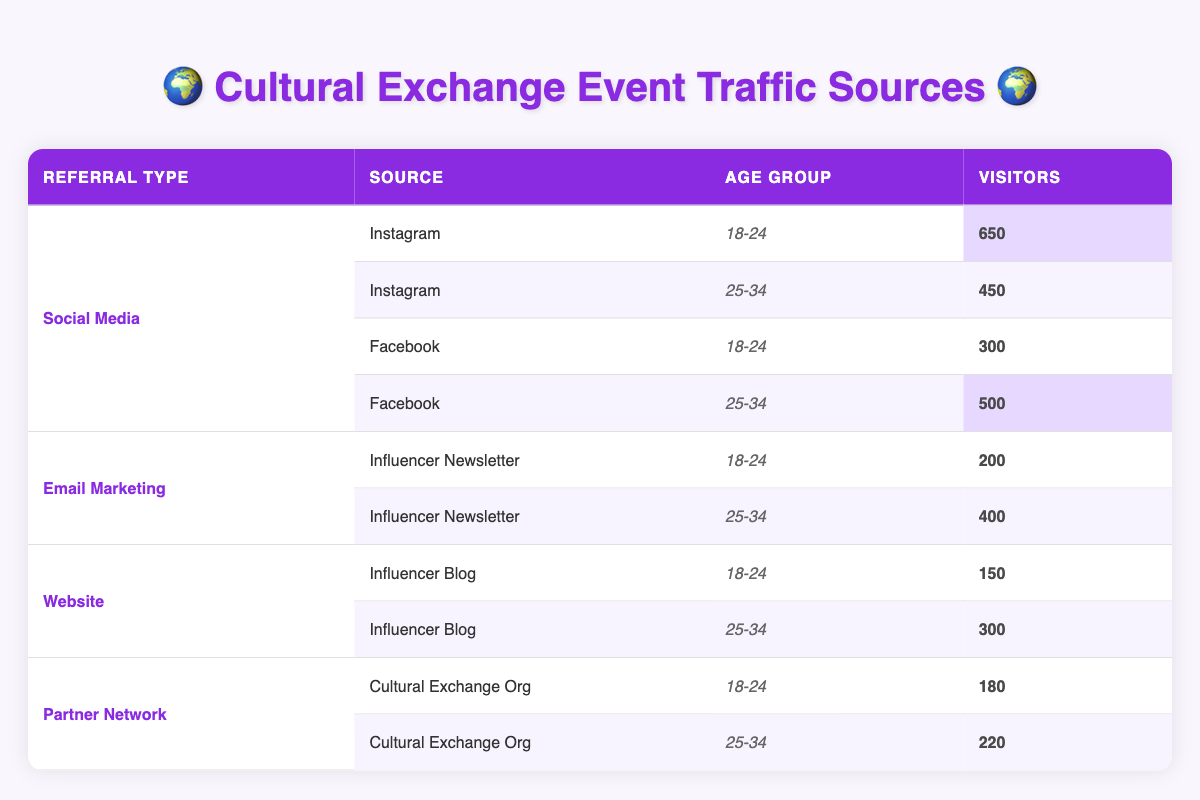What is the total number of visitors from Instagram aged 18-24? From the table, the value for Instagram in the age group 18-24 is 650 visitors. Since there are no other entries for Instagram under this age group, the total count remains 650.
Answer: 650 How many visitors came from Email Marketing in the age group 25-34? According to the table, for Email Marketing with the campaign "Influencer Newsletter" in the age group 25-34, there are 400 visitors.
Answer: 400 Which referral type had the highest number of visitors in the 18-24 age group? In the 18-24 age group, Social Media (Instagram) has the highest number of visitors at 650, compared to other referral types.
Answer: Social Media (Instagram) What is the difference in the number of visitors from Facebook between the two age groups? The number of visitors from Facebook is 300 for the 18-24 age group and 500 for the 25-34 age group. The difference is 500 - 300 = 200.
Answer: 200 Did more visitors come from the Influencer Newsletter or the Influencer Blog in the 25-34 age group? For the 25-34 age group, the Influencer Newsletter has 400 visitors while the Influencer Blog has 300 visitors. So, more visitors came from the Influencer Newsletter.
Answer: Yes What is the total number of visitors from all sources combined for the 25-34 age group? Adding the visitors for the 25-34 age group: Instagram (450) + Facebook (500) + Email Marketing (400) + Influencer Blog (300) + Partner Network (220) gives a total of 450 + 500 + 400 + 300 + 220 = 1870 visitors.
Answer: 1870 From which source in the Partner Network did the 18-24 age group have more visitors? The table indicates that in the 18-24 age group, the "Cultural Exchange Org" from the Partner Network had 180 visitors. There are no other sources listed for this age group in the Partner Network, so the answer is 180.
Answer: 180 What percentage of the total visitors from Social Media came from Instagram in the 25-34 age group? For Social Media in the 25-34 age group, the total visitors from Instagram is 450, and from Facebook is 500, making the total 950. Thus, the percentage for Instagram is (450/950)*100 = 47.37%, which rounds to approximately 47%.
Answer: 47% Which referral type had the least number of visitors in the 18-24 age group? In the 18-24 age group, the least number of visitors is 150 from the "Influencer Blog," compared to all other referral types listed under this age group, making this the lowest.
Answer: Influencer Blog 